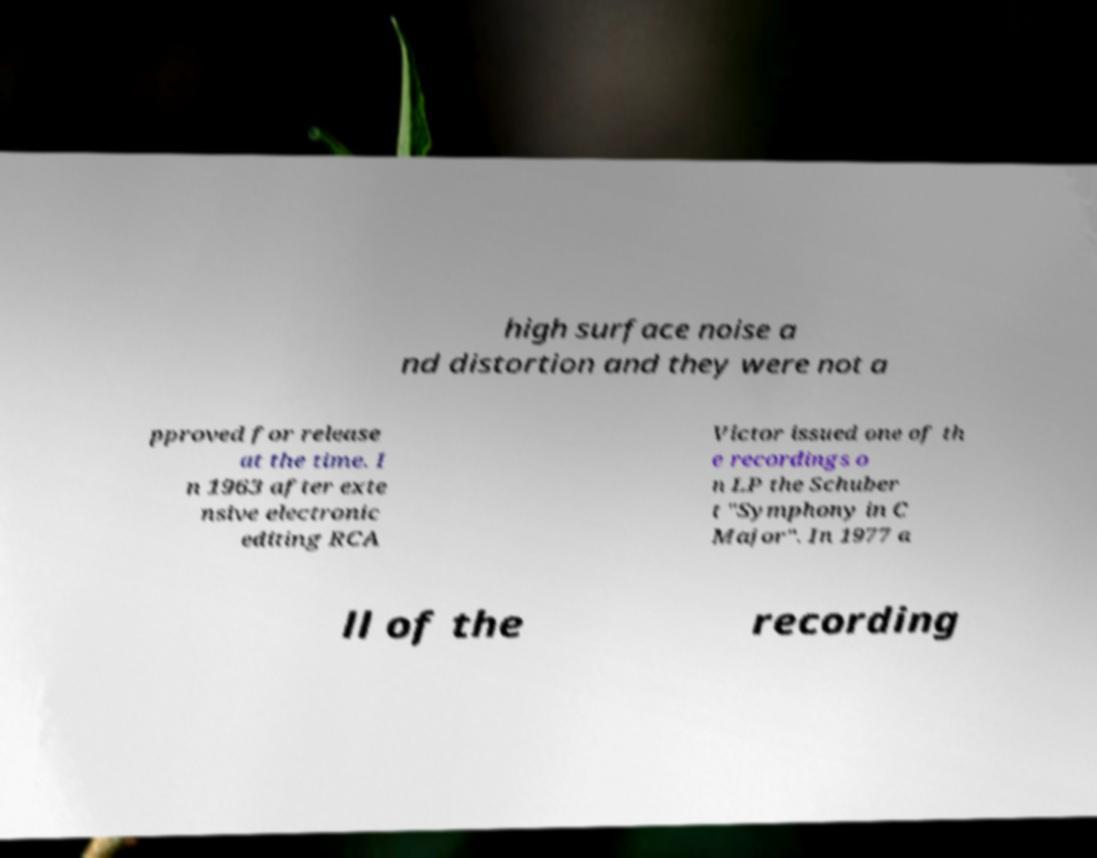For documentation purposes, I need the text within this image transcribed. Could you provide that? high surface noise a nd distortion and they were not a pproved for release at the time. I n 1963 after exte nsive electronic editing RCA Victor issued one of th e recordings o n LP the Schuber t "Symphony in C Major". In 1977 a ll of the recording 